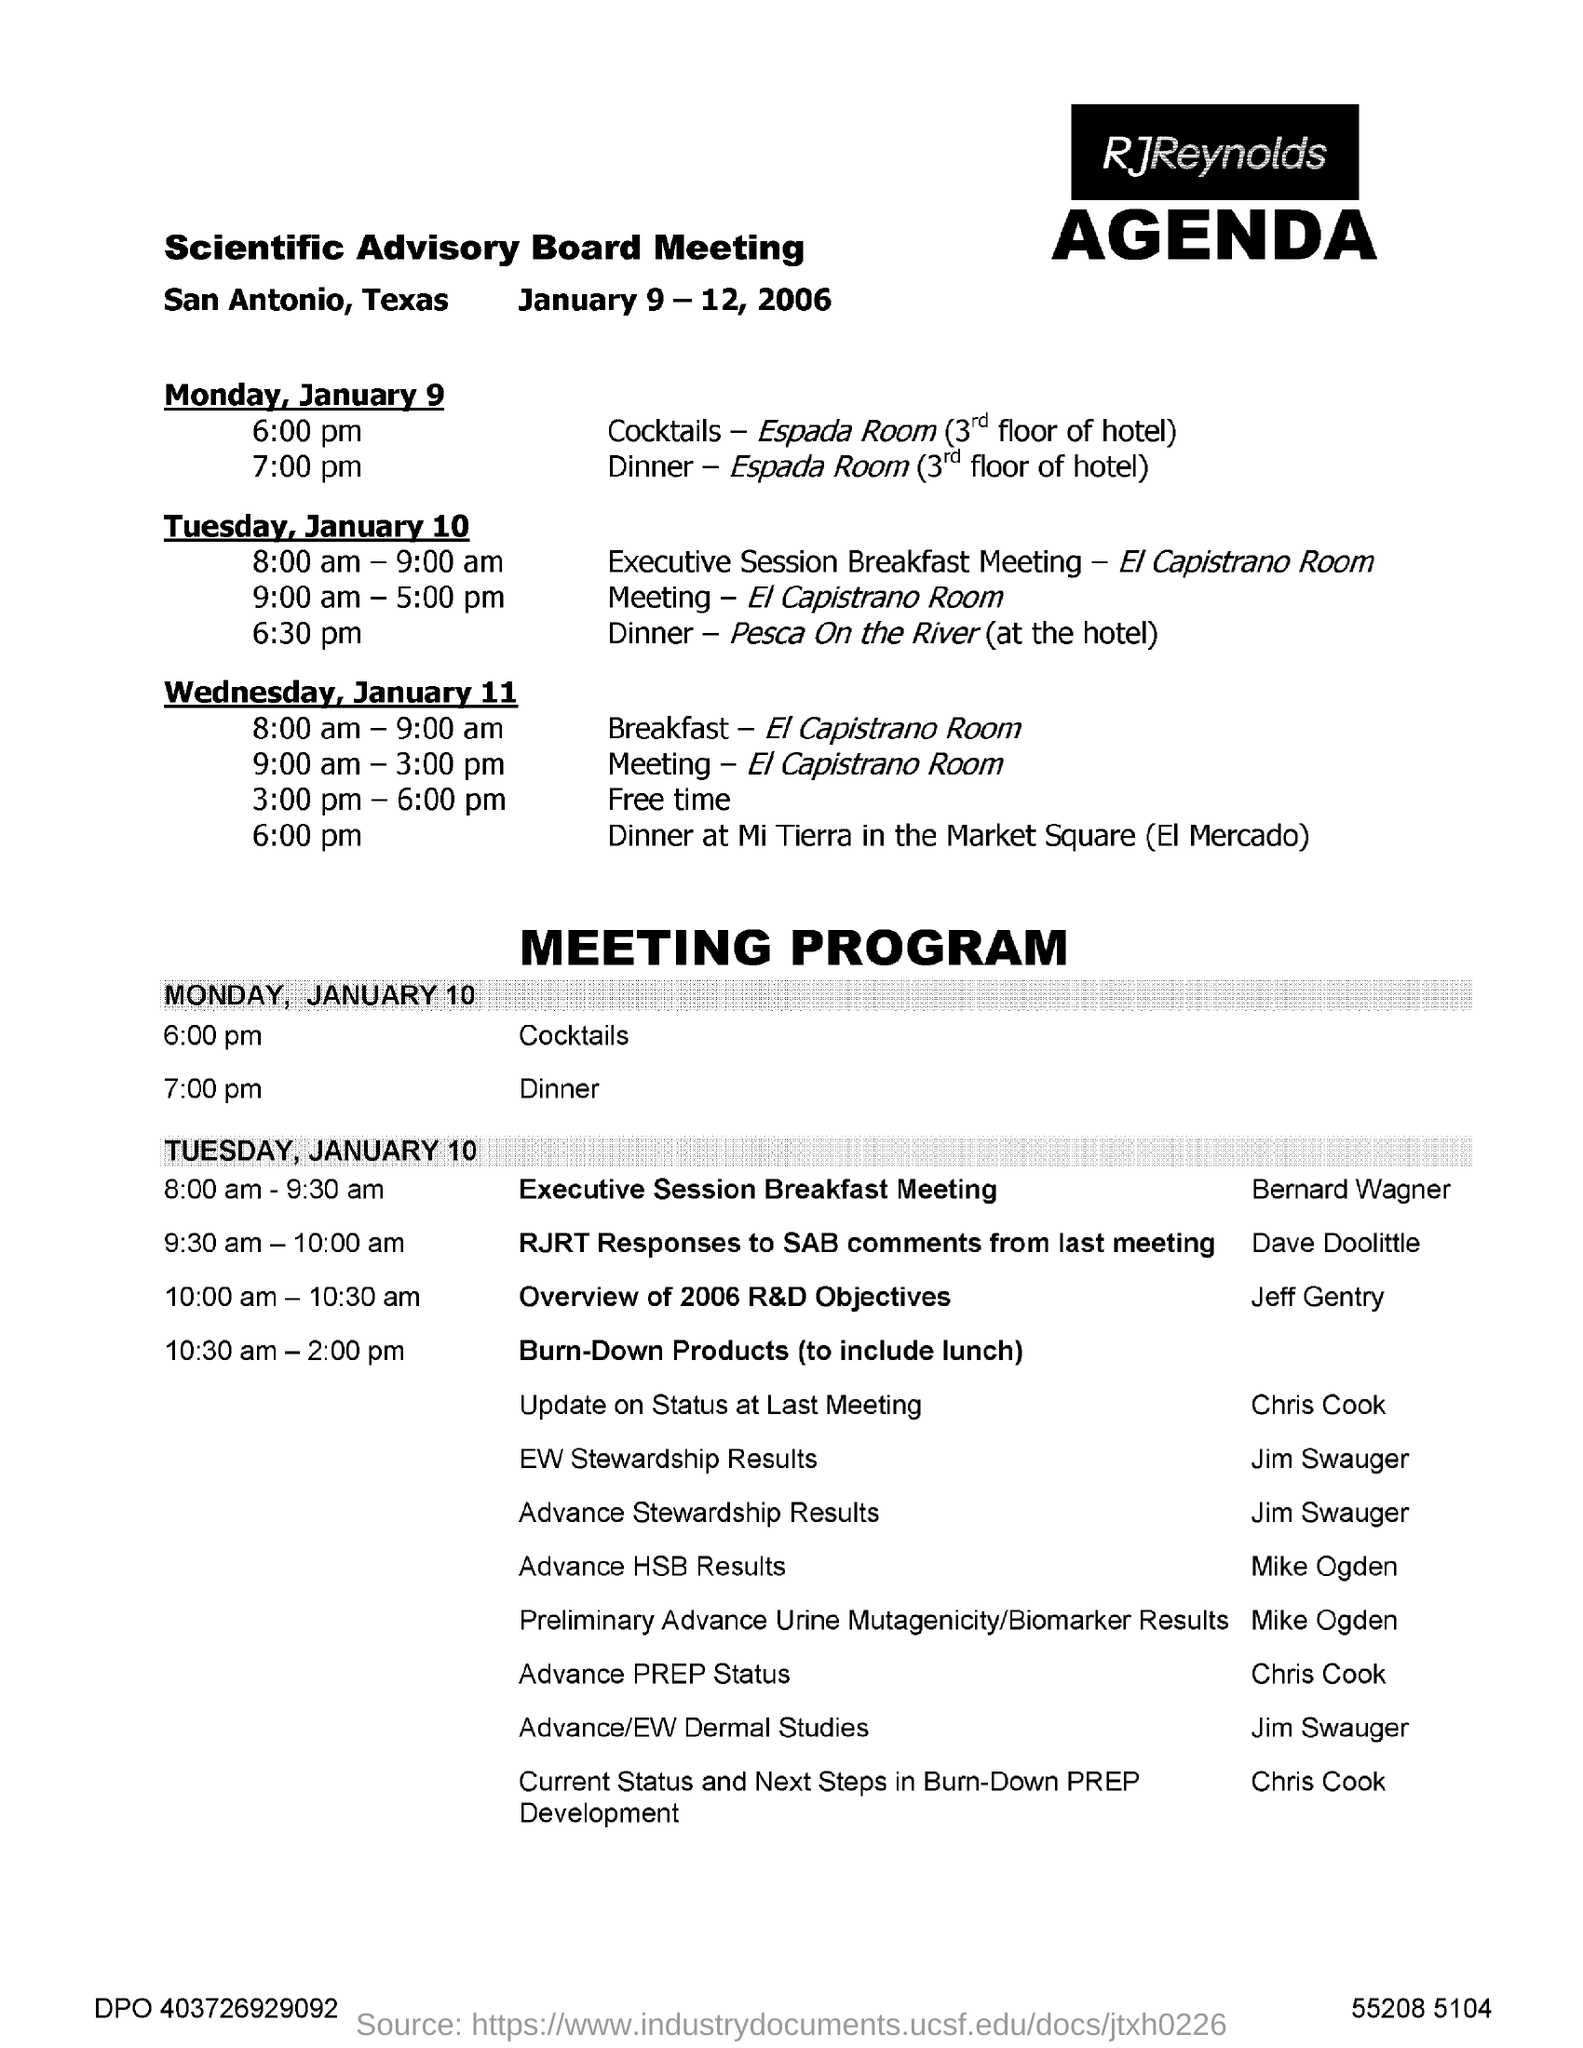When is the Scientific Advisory Board meeting scheduled?
Provide a succinct answer. January 9 - 12, 2006. Where is the Scientific Advisory Board meeting held?
Provide a succinct answer. San Antonio, Texas. 